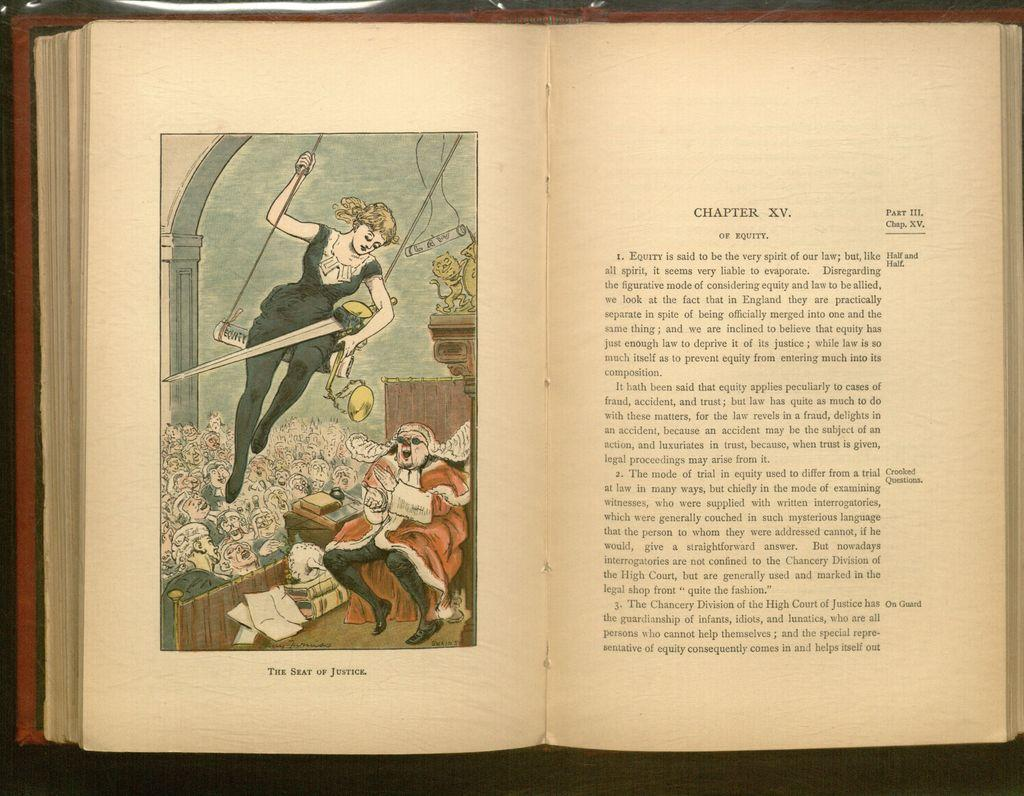<image>
Offer a succinct explanation of the picture presented. an open book to a picture of a trapeze artist and Chapter XV 